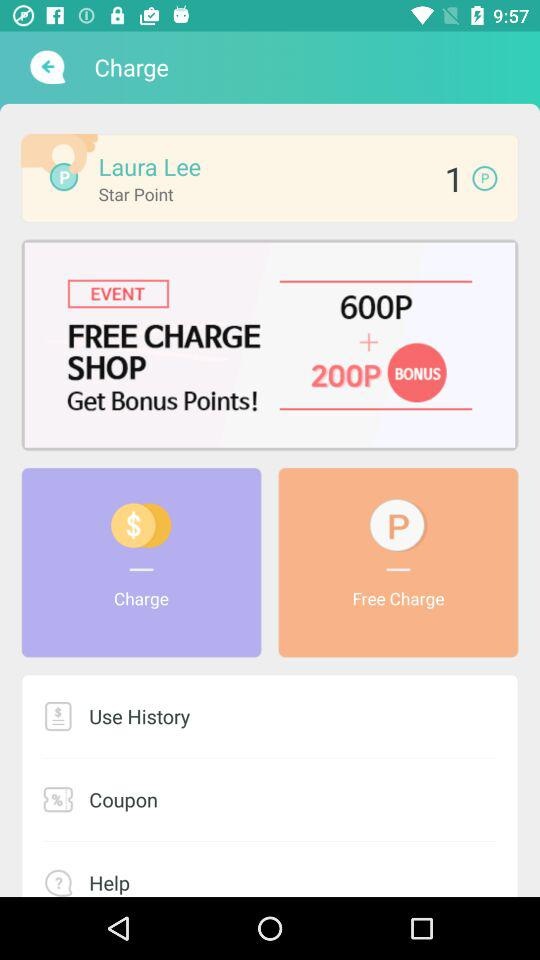How many bonus points are there? There are 200 bonus points. 